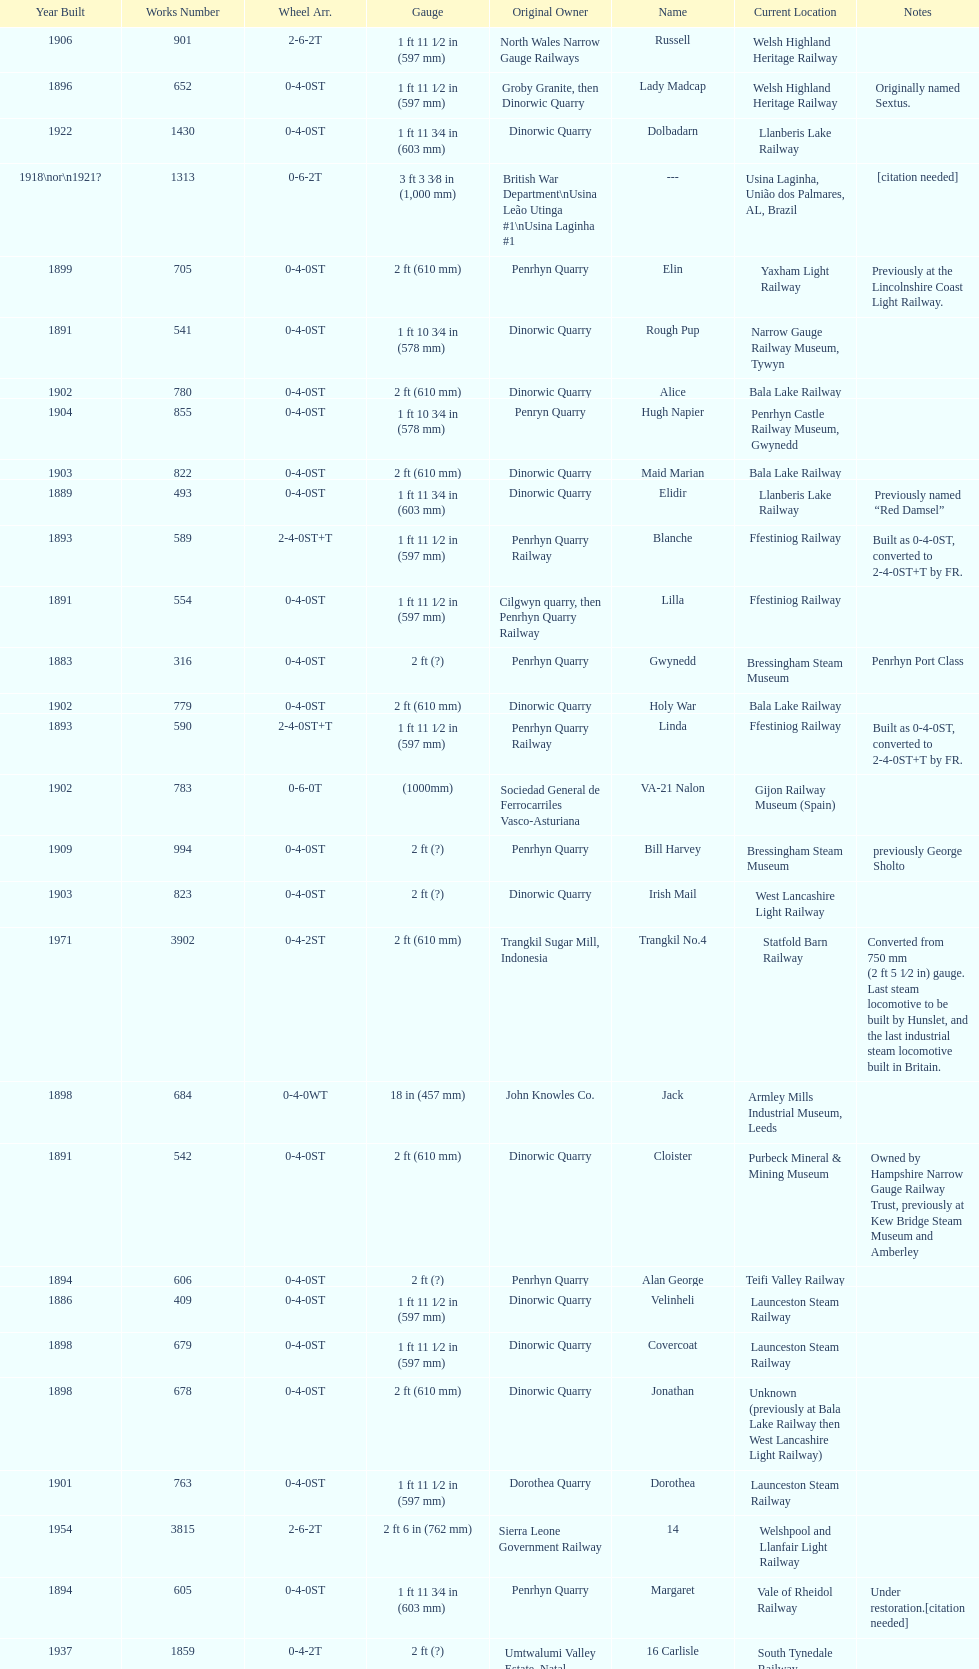Which original owner had the most locomotives? Penrhyn Quarry. 